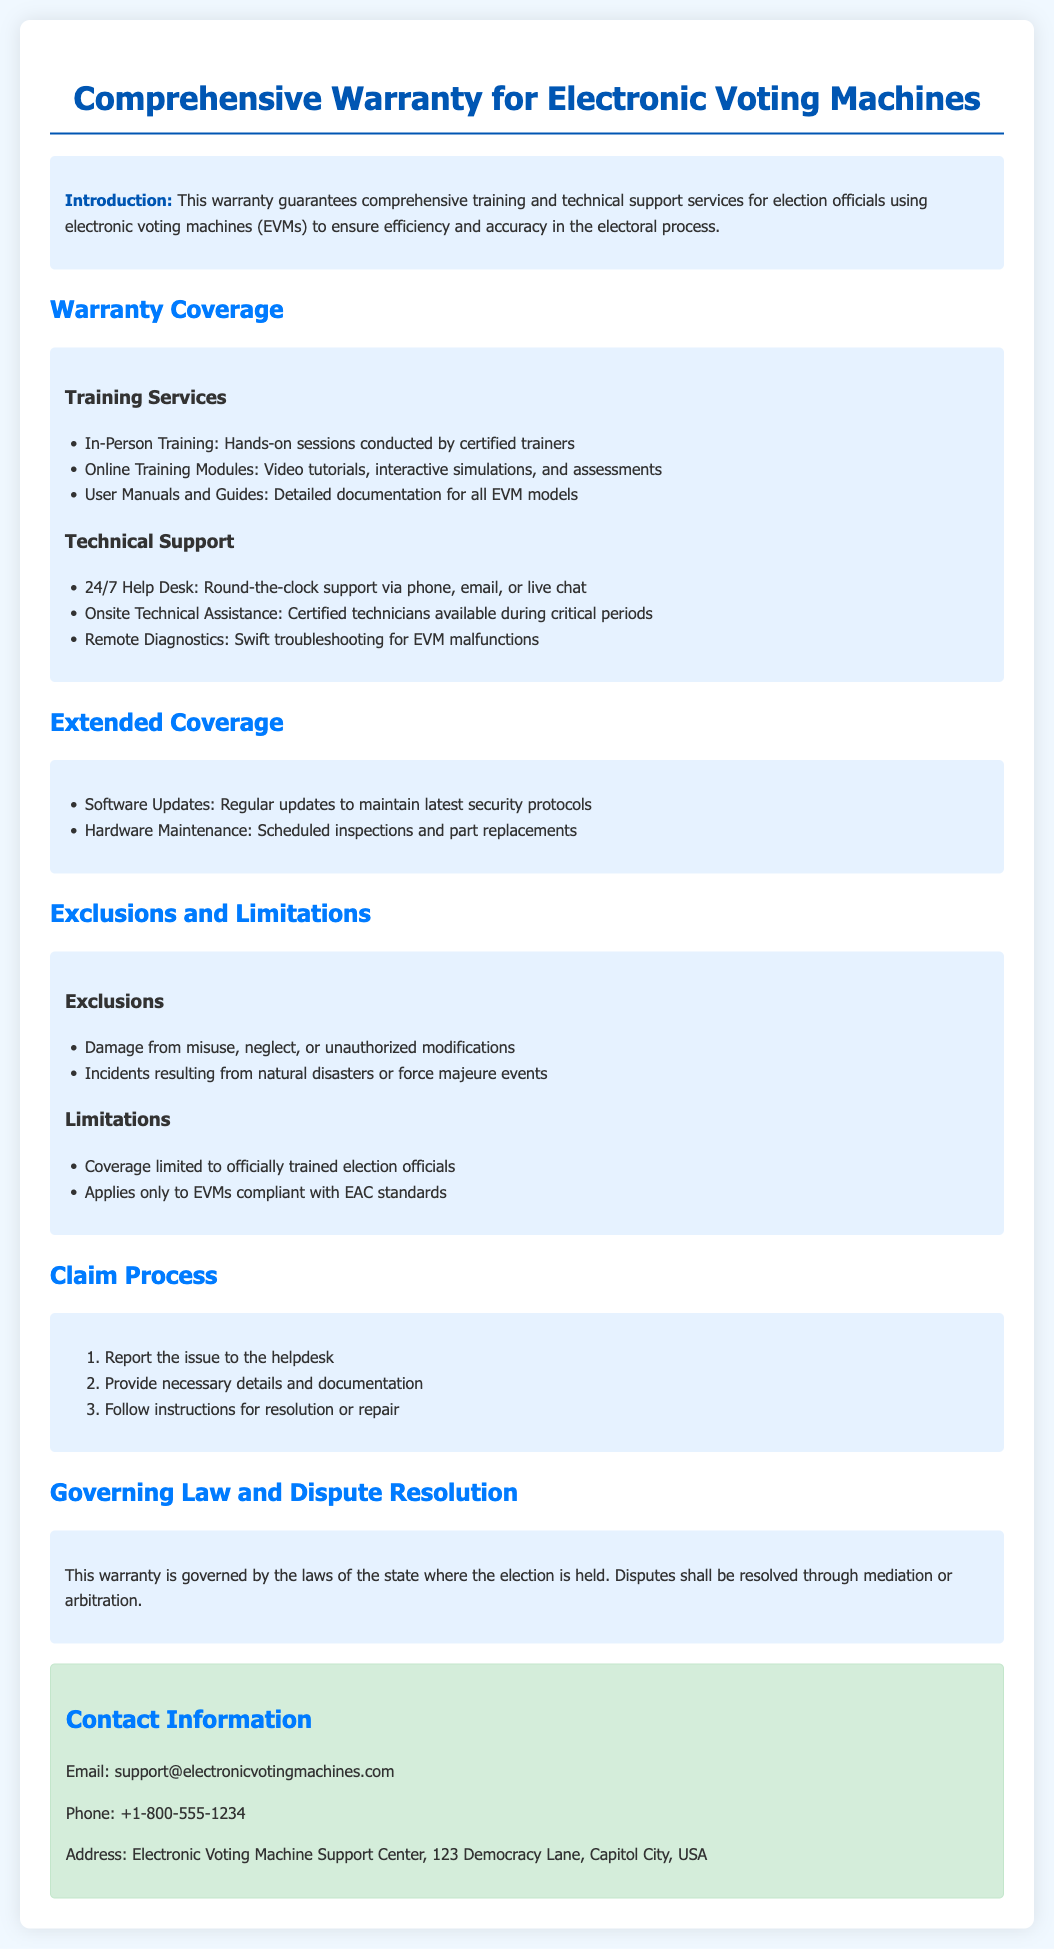What is included in the training services? The document lists in-person training, online training modules, and user manuals and guides as the components of training services.
Answer: In-Person Training, Online Training Modules, User Manuals and Guides What type of support is available 24/7? The warranty specifies that there is a help desk providing round-the-clock support via phone, email, or live chat.
Answer: Help Desk What is one of the exclusions mentioned in the warranty? Among the exclusions, damage from misuse or neglect is specifically mentioned as not covered under the warranty.
Answer: Damage from misuse What types of incidents are not covered under this warranty? The warranty outlines situations such as natural disasters and unauthorized modifications as exclusions to the coverage.
Answer: Natural disasters What is the first step in the claim process? The document details that the first step to take when claiming under the warranty is to report the issue to the helpdesk.
Answer: Report the issue What is required for coverage under the warranty? Coverage is limited to officially trained election officials, as noted in the limitations section of the document.
Answer: Officially trained election officials Which law governs the warranty? The warranty states it is governed by the laws of the state where the election is held, indicating jurisdiction.
Answer: The state where the election is held What are the contact details provided? The document provides an email, phone number, and address for support inquiries, which are essential for contacting the service center.
Answer: support@electronicvotingmachines.com, +1-800-555-1234, Electronic Voting Machine Support Center, 123 Democracy Lane, Capitol City, USA 